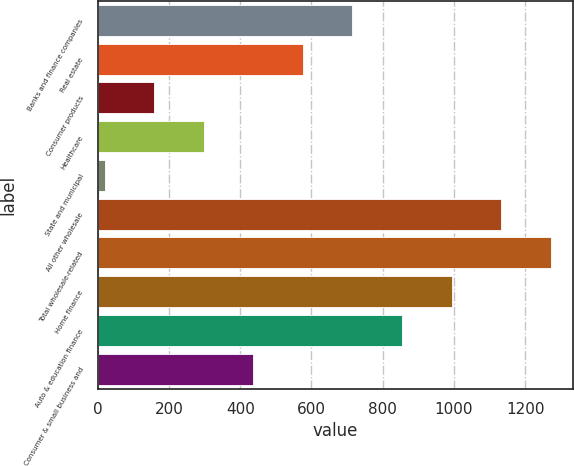<chart> <loc_0><loc_0><loc_500><loc_500><bar_chart><fcel>Banks and finance companies<fcel>Real estate<fcel>Consumer products<fcel>Healthcare<fcel>State and municipal<fcel>All other wholesale<fcel>Total wholesale-related<fcel>Home finance<fcel>Auto & education finance<fcel>Consumer & small business and<nl><fcel>715.1<fcel>576.04<fcel>158.86<fcel>297.92<fcel>19.8<fcel>1132.28<fcel>1271.34<fcel>993.22<fcel>854.16<fcel>436.98<nl></chart> 